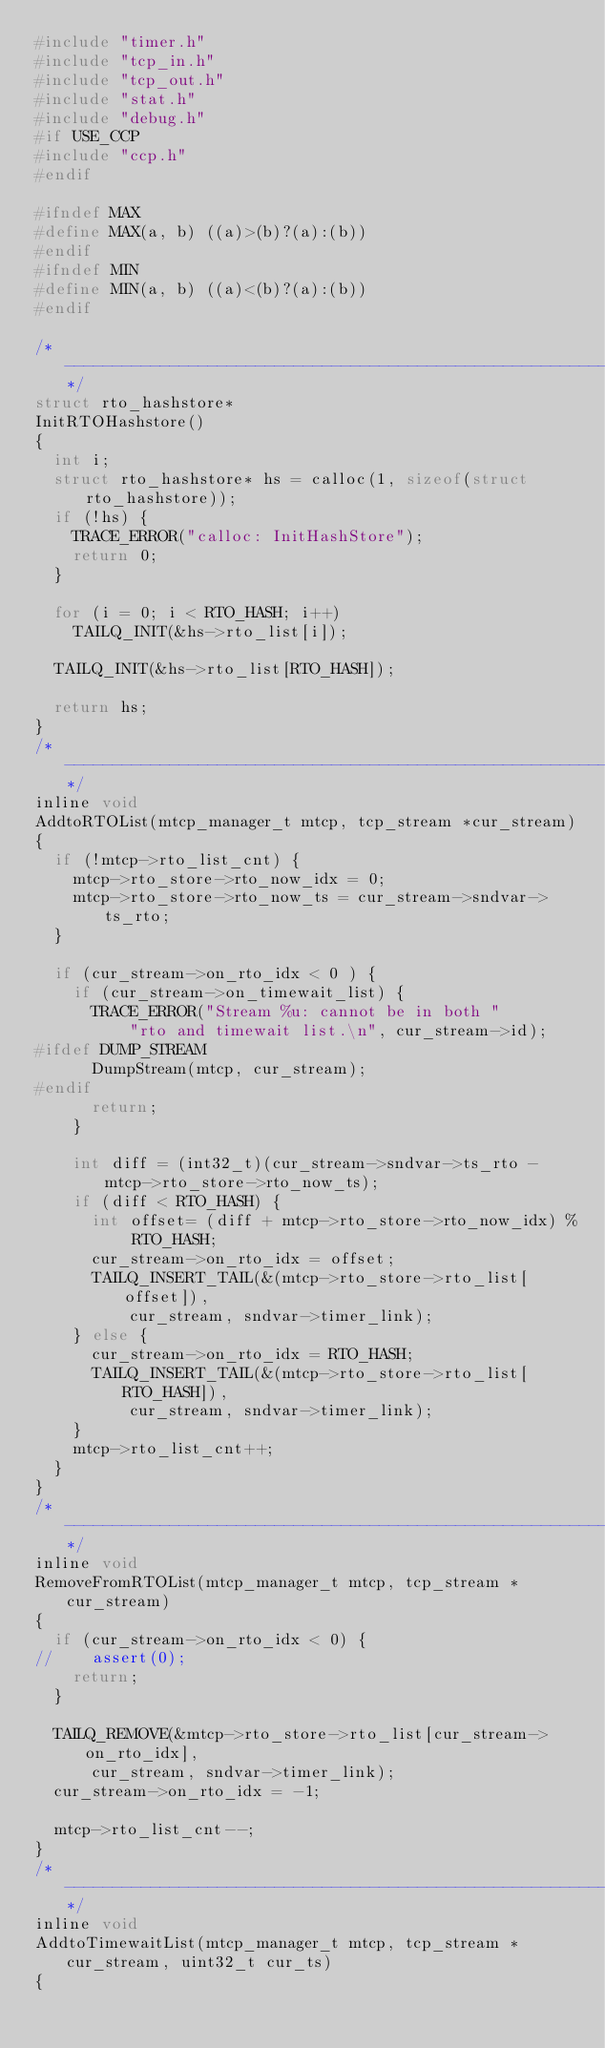Convert code to text. <code><loc_0><loc_0><loc_500><loc_500><_C_>#include "timer.h"
#include "tcp_in.h"
#include "tcp_out.h"
#include "stat.h"
#include "debug.h"
#if USE_CCP
#include "ccp.h"
#endif

#ifndef MAX
#define MAX(a, b) ((a)>(b)?(a):(b))
#endif
#ifndef MIN
#define MIN(a, b) ((a)<(b)?(a):(b))
#endif

/*----------------------------------------------------------------------------*/
struct rto_hashstore*
InitRTOHashstore()
{
	int i;
	struct rto_hashstore* hs = calloc(1, sizeof(struct rto_hashstore));
	if (!hs) {
		TRACE_ERROR("calloc: InitHashStore");
		return 0;
	}

	for (i = 0; i < RTO_HASH; i++)
		TAILQ_INIT(&hs->rto_list[i]);
		
	TAILQ_INIT(&hs->rto_list[RTO_HASH]);

	return hs;
}
/*----------------------------------------------------------------------------*/
inline void 
AddtoRTOList(mtcp_manager_t mtcp, tcp_stream *cur_stream)
{
	if (!mtcp->rto_list_cnt) {
		mtcp->rto_store->rto_now_idx = 0;
		mtcp->rto_store->rto_now_ts = cur_stream->sndvar->ts_rto;
	}

	if (cur_stream->on_rto_idx < 0 ) {
		if (cur_stream->on_timewait_list) {
			TRACE_ERROR("Stream %u: cannot be in both "
					"rto and timewait list.\n", cur_stream->id);
#ifdef DUMP_STREAM
			DumpStream(mtcp, cur_stream);
#endif
			return;
		}

		int diff = (int32_t)(cur_stream->sndvar->ts_rto - mtcp->rto_store->rto_now_ts);
		if (diff < RTO_HASH) {
			int offset= (diff + mtcp->rto_store->rto_now_idx) % RTO_HASH;
			cur_stream->on_rto_idx = offset;
			TAILQ_INSERT_TAIL(&(mtcp->rto_store->rto_list[offset]), 
					cur_stream, sndvar->timer_link);
		} else {
			cur_stream->on_rto_idx = RTO_HASH;
			TAILQ_INSERT_TAIL(&(mtcp->rto_store->rto_list[RTO_HASH]), 
					cur_stream, sndvar->timer_link);
		}
		mtcp->rto_list_cnt++;
	}
}
/*----------------------------------------------------------------------------*/
inline void 
RemoveFromRTOList(mtcp_manager_t mtcp, tcp_stream *cur_stream)
{
	if (cur_stream->on_rto_idx < 0) {
//		assert(0);
		return;
	}
	
	TAILQ_REMOVE(&mtcp->rto_store->rto_list[cur_stream->on_rto_idx], 
			cur_stream, sndvar->timer_link);
	cur_stream->on_rto_idx = -1;

	mtcp->rto_list_cnt--;
}
/*----------------------------------------------------------------------------*/
inline void 
AddtoTimewaitList(mtcp_manager_t mtcp, tcp_stream *cur_stream, uint32_t cur_ts)
{</code> 